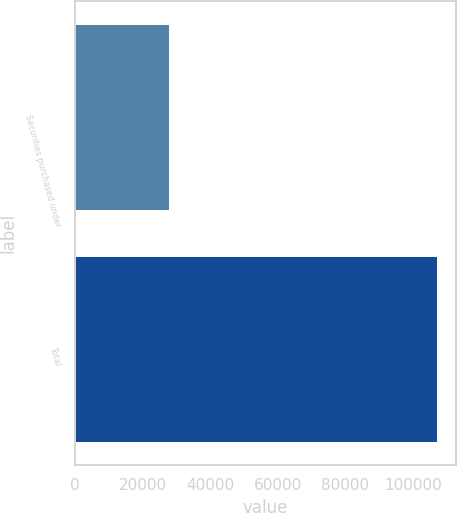Convert chart to OTSL. <chart><loc_0><loc_0><loc_500><loc_500><bar_chart><fcel>Securities purchased under<fcel>Total<nl><fcel>27962<fcel>107185<nl></chart> 